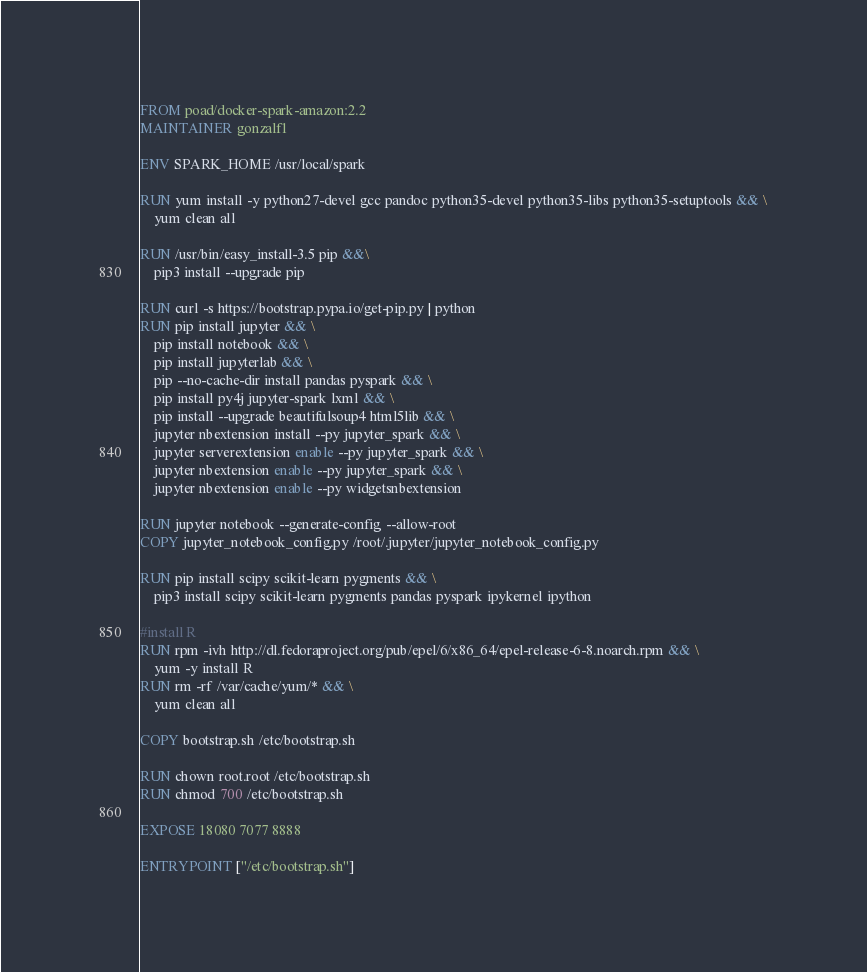Convert code to text. <code><loc_0><loc_0><loc_500><loc_500><_Dockerfile_>FROM poad/docker-spark-amazon:2.2
MAINTAINER gonzalf1

ENV SPARK_HOME /usr/local/spark

RUN yum install -y python27-devel gcc pandoc python35-devel python35-libs python35-setuptools && \
    yum clean all

RUN /usr/bin/easy_install-3.5 pip &&\
    pip3 install --upgrade pip

RUN curl -s https://bootstrap.pypa.io/get-pip.py | python
RUN pip install jupyter && \
    pip install notebook && \
    pip install jupyterlab && \
    pip --no-cache-dir install pandas pyspark && \
    pip install py4j jupyter-spark lxml && \
    pip install --upgrade beautifulsoup4 html5lib && \
    jupyter nbextension install --py jupyter_spark && \
    jupyter serverextension enable --py jupyter_spark && \
    jupyter nbextension enable --py jupyter_spark && \
    jupyter nbextension enable --py widgetsnbextension

RUN jupyter notebook --generate-config --allow-root
COPY jupyter_notebook_config.py /root/.jupyter/jupyter_notebook_config.py

RUN pip install scipy scikit-learn pygments && \
    pip3 install scipy scikit-learn pygments pandas pyspark ipykernel ipython

#install R
RUN rpm -ivh http://dl.fedoraproject.org/pub/epel/6/x86_64/epel-release-6-8.noarch.rpm && \
    yum -y install R
RUN rm -rf /var/cache/yum/* && \
    yum clean all

COPY bootstrap.sh /etc/bootstrap.sh

RUN chown root.root /etc/bootstrap.sh
RUN chmod 700 /etc/bootstrap.sh

EXPOSE 18080 7077 8888

ENTRYPOINT ["/etc/bootstrap.sh"]

</code> 